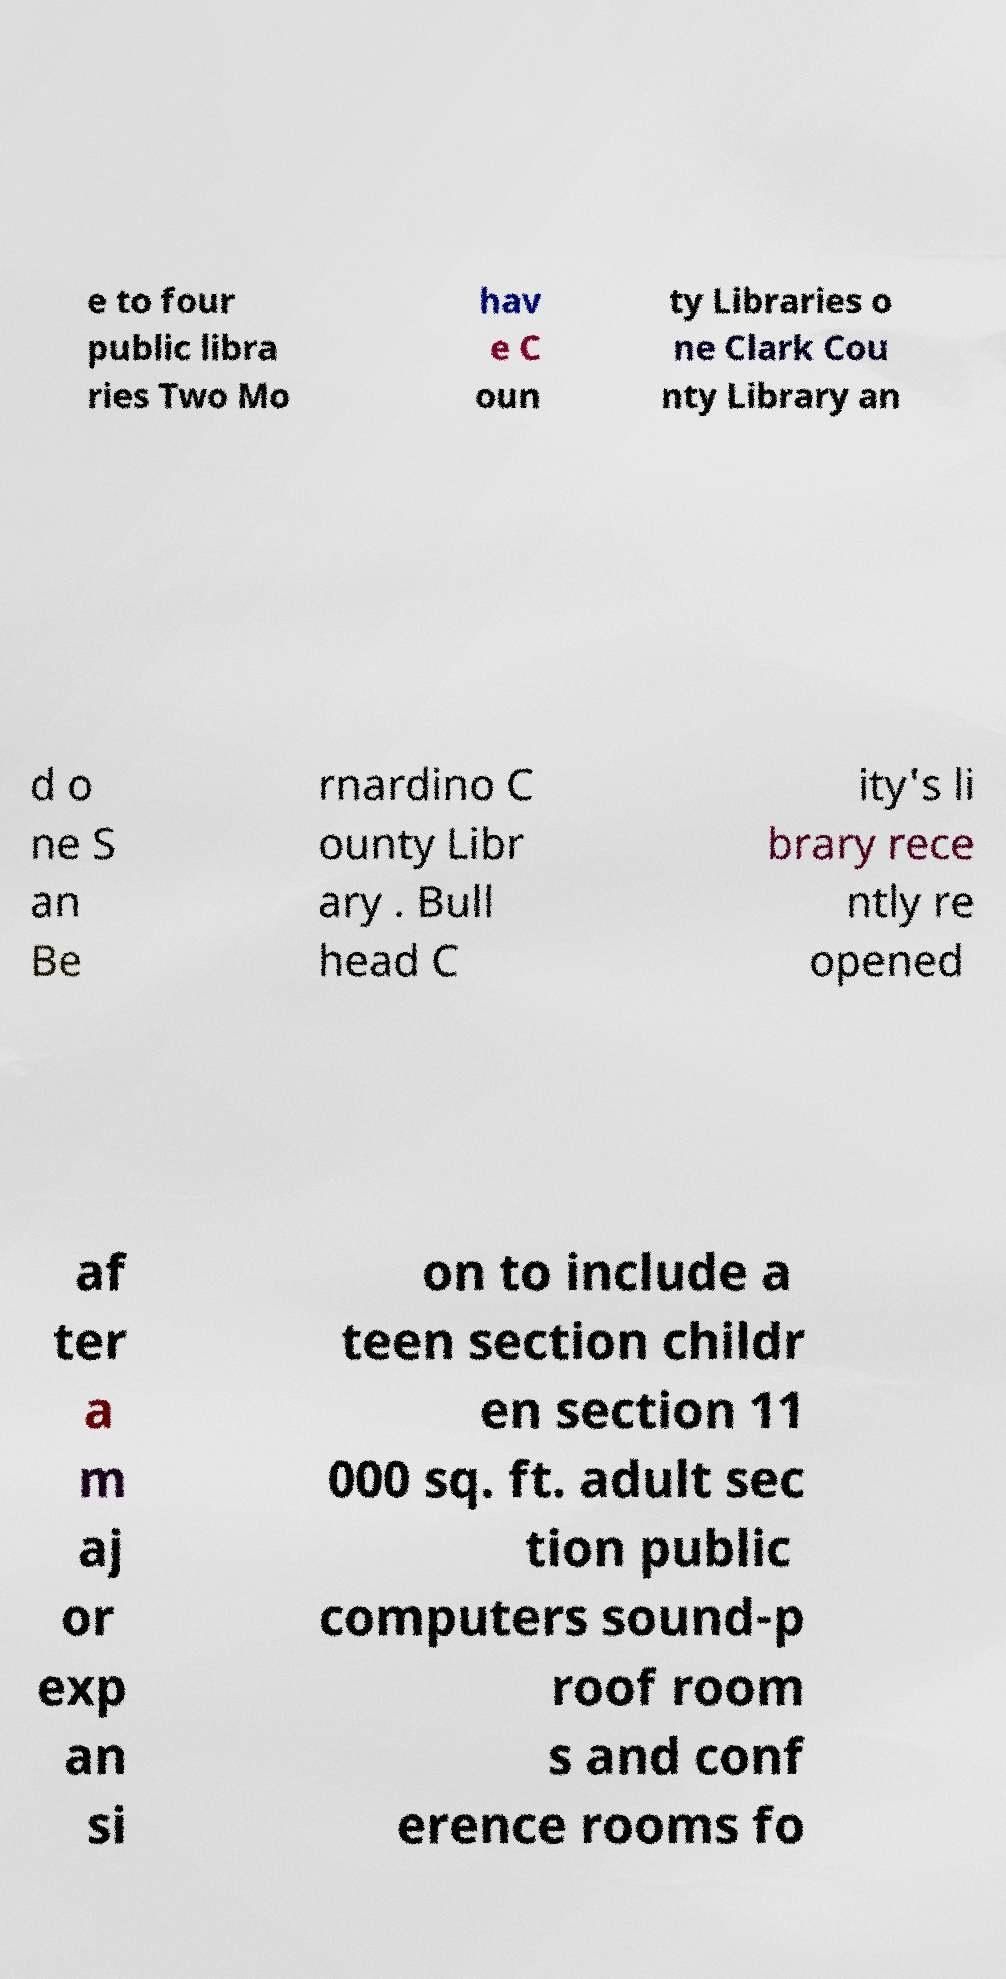There's text embedded in this image that I need extracted. Can you transcribe it verbatim? e to four public libra ries Two Mo hav e C oun ty Libraries o ne Clark Cou nty Library an d o ne S an Be rnardino C ounty Libr ary . Bull head C ity's li brary rece ntly re opened af ter a m aj or exp an si on to include a teen section childr en section 11 000 sq. ft. adult sec tion public computers sound-p roof room s and conf erence rooms fo 